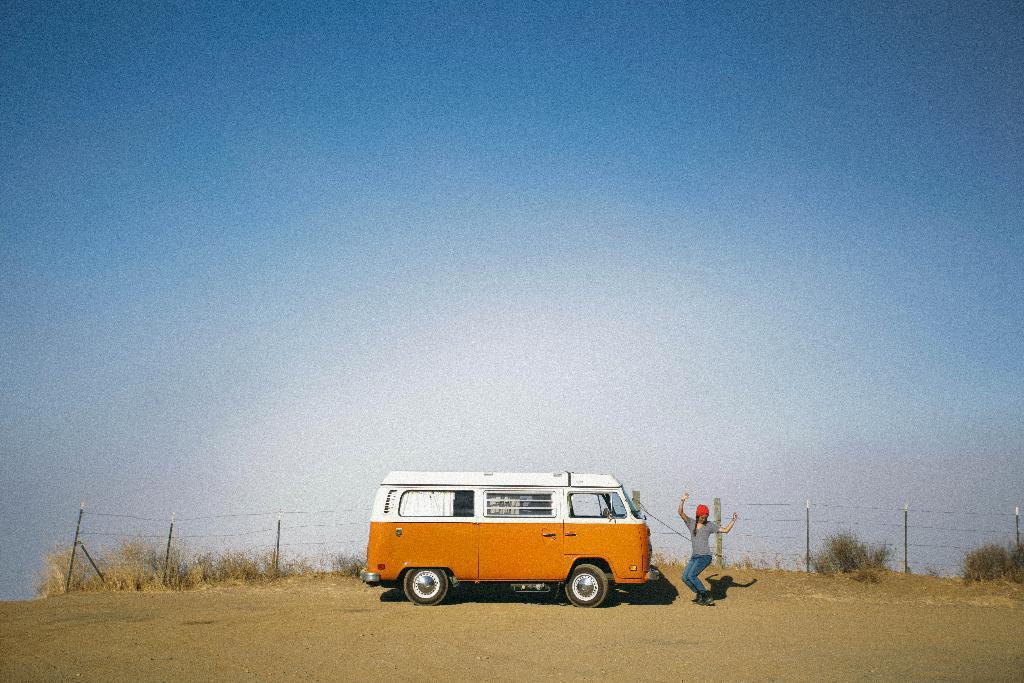Can you describe this image briefly? In this image we can see a motor vehicle and a woman standing on the road. In the background there are shrubs, bushes, an iron fence and sky with clouds. 